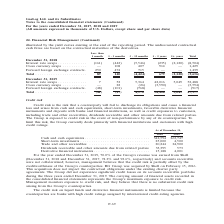According to Gaslog's financial document, How does the Group limit its exposure to credit risk? To limit this risk, the Group currently deals primarily with financial institutions and customers with high credit ratings.. The document states: "t of non-performance by any of its counterparties. To limit this risk, the Group currently deals primarily with financial institutions and customers w..." Also, When did Shell acquire BG Group? According to the financial document, February 15, 2016. The relevant text states: "counterparties. BG Group was acquired by Shell on February 15, 2016. This acquisition does not impact the contractual obligations under the existing charter party agre..." Also, What are the components subjected to credit risk? The document contains multiple relevant values: Cash and cash equivalents, Short-term investments, Trade and other receivables, Dividends receivable and other amounts due from related parties, Derivative financial instruments. From the document: "4,500 Trade and other receivables . 20,244 24,900 Dividends receivable and other amounts due from related parties 33,395 573 Derivative financial inst..." Additionally, Which year was the cash and cash equivalents higher? According to the financial document, 2018. The relevant text states: "Continued) For the years ended December 31, 2017, 2018 and 2019 (All amounts expressed in thousands of U.S. Dollars, except share and per share data)..." Also, can you calculate: What was the change in short-term investments from 2018 to 2019? Based on the calculation: 4,500 - 25,000 , the result is -20500 (in thousands). This is based on the information: ". 342,594 263,747 Short-term investments . 25,000 4,500 Trade and other receivables . 20,244 24,900 Dividends receivable and other amounts due from related alents . 342,594 263,747 Short-term investme..." The key data points involved are: 25,000, 4,500. Also, can you calculate: What was the percentage change in derivative financial instruments from 2018 to 2019? To answer this question, I need to perform calculations using the financial data. The calculation is: (4,001 - 15,188)/15,188 , which equals -73.66 (percentage). This is based on the information: "ies 33,395 573 Derivative financial instruments . 15,188 4,001 395 573 Derivative financial instruments . 15,188 4,001..." The key data points involved are: 15,188, 4,001. 